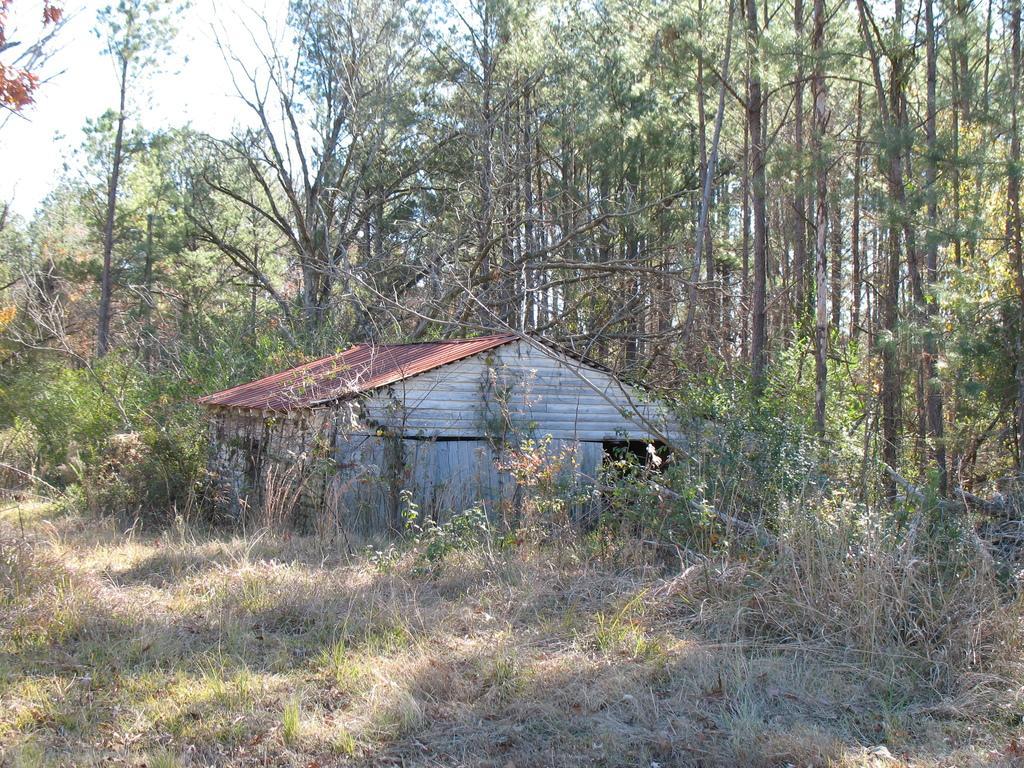Describe this image in one or two sentences. In this picture we can see grass, plants, shed and trees. In the background of the image we can see the sky. 